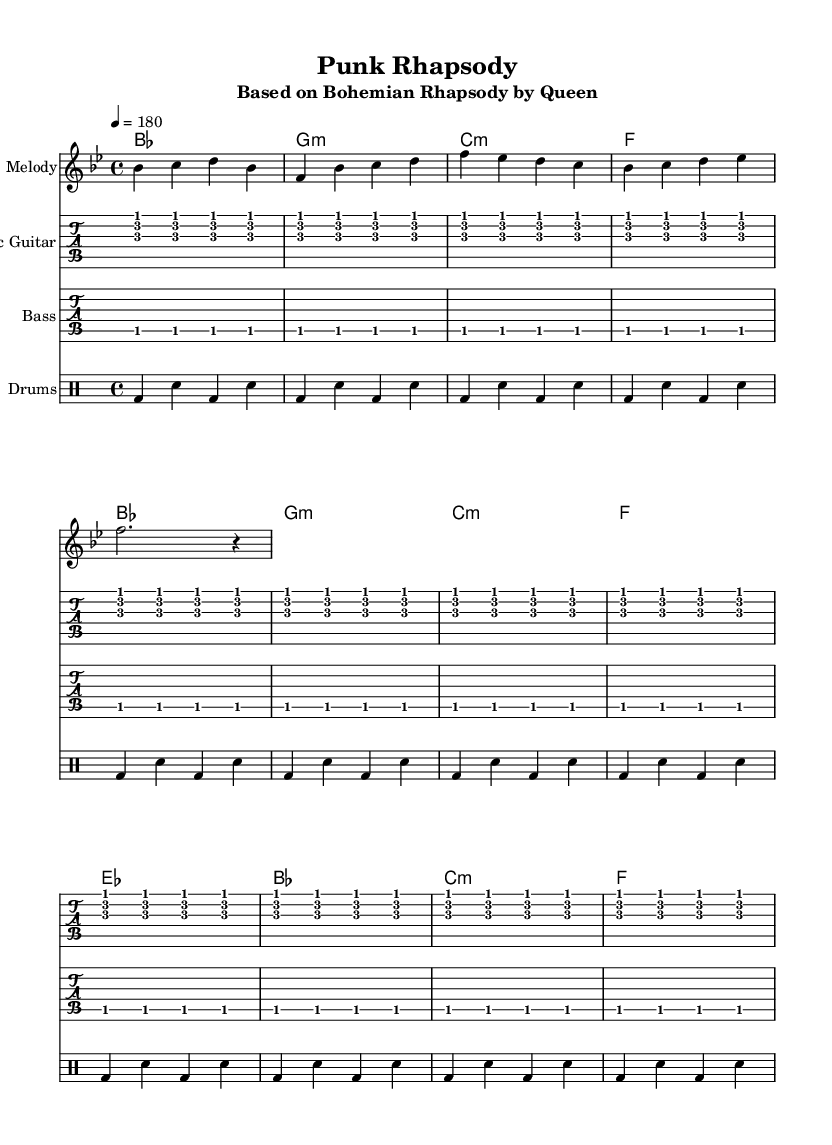What is the key signature of this music? The key signature is B flat major, which includes two flat notes: B flat and E flat. This is indicated at the beginning of the staff.
Answer: B flat major What is the time signature of the piece? The time signature is 4/4, meaning there are four beats in each measure and the quarter note gets one beat. This is shown in the initial part of the music notation.
Answer: 4/4 What is the tempo marking for this piece? The tempo marking is 180 beats per minute, indicated as "4 = 180" in the score. This indicates the speed at which the piece should be played.
Answer: 180 How many measures are repeated in the electric guitar part? The electric guitar part indicates that a total of twelve measures of the same pattern are repeated. This can be determined by the 'repeat' directive shown in the part notation.
Answer: 12 What type of drum beat is used in this arrangement? The drum beat consists of a bass drum (bd) on the first and third beat, and a snare drum (sn) on the second and fourth beats, providing a standard rock rhythm.
Answer: Standard rock rhythm How many notes are played in the melody's first measure? The first measure contains four notes: B flat, C, D, and B flat again, as seen in the melodic line for that measure.
Answer: 4 What is the overall musical genre this piece is aiming to embody? The piece, titled "Punk Rhapsody," clearly aims to interpret classic Queen anthems through the lens of punk rock, fitting the theme suggested by its title.
Answer: Punk rock 